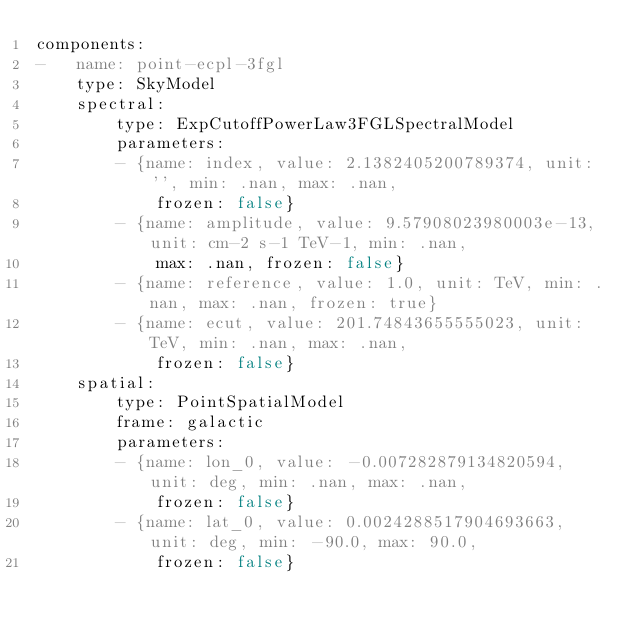<code> <loc_0><loc_0><loc_500><loc_500><_YAML_>components:
-   name: point-ecpl-3fgl
    type: SkyModel
    spectral:
        type: ExpCutoffPowerLaw3FGLSpectralModel
        parameters:
        - {name: index, value: 2.1382405200789374, unit: '', min: .nan, max: .nan,
            frozen: false}
        - {name: amplitude, value: 9.57908023980003e-13, unit: cm-2 s-1 TeV-1, min: .nan,
            max: .nan, frozen: false}
        - {name: reference, value: 1.0, unit: TeV, min: .nan, max: .nan, frozen: true}
        - {name: ecut, value: 201.74843655555023, unit: TeV, min: .nan, max: .nan,
            frozen: false}
    spatial:
        type: PointSpatialModel
        frame: galactic
        parameters:
        - {name: lon_0, value: -0.007282879134820594, unit: deg, min: .nan, max: .nan,
            frozen: false}
        - {name: lat_0, value: 0.0024288517904693663, unit: deg, min: -90.0, max: 90.0,
            frozen: false}
</code> 